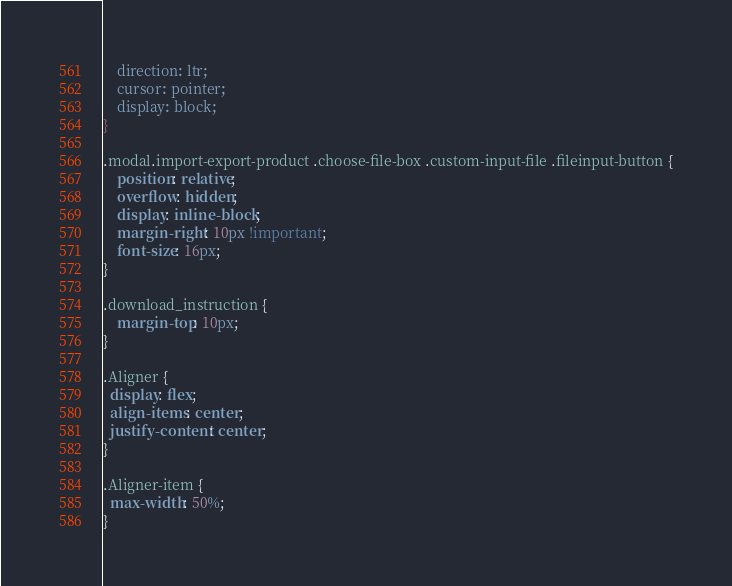<code> <loc_0><loc_0><loc_500><loc_500><_CSS_>    direction: ltr;
    cursor: pointer;
    display: block;
}

.modal.import-export-product .choose-file-box .custom-input-file .fileinput-button {
    position: relative;
    overflow: hidden;
    display: inline-block;
    margin-right: 10px !important;
    font-size: 16px;
}

.download_instruction {
    margin-top: 10px;
}

.Aligner {
  display: flex;
  align-items: center;
  justify-content: center;
}

.Aligner-item {
  max-width: 50%;
}
</code> 